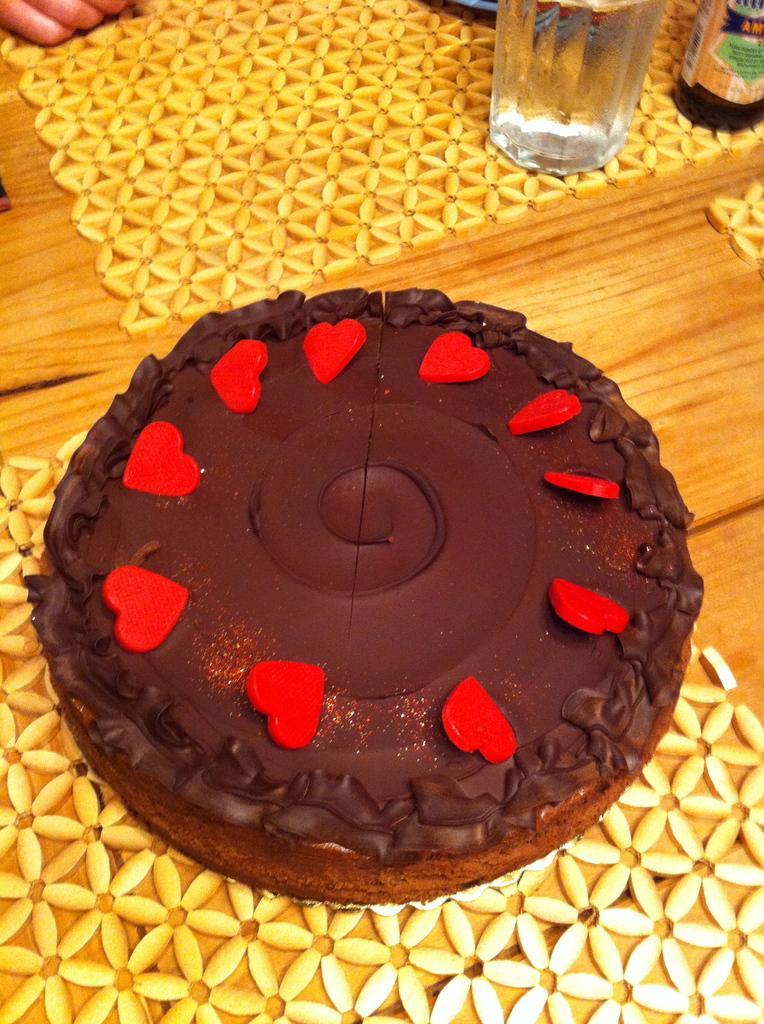Can you describe this image briefly? In the image I can see a table on which there are two mats, cake and a glass to the side. 